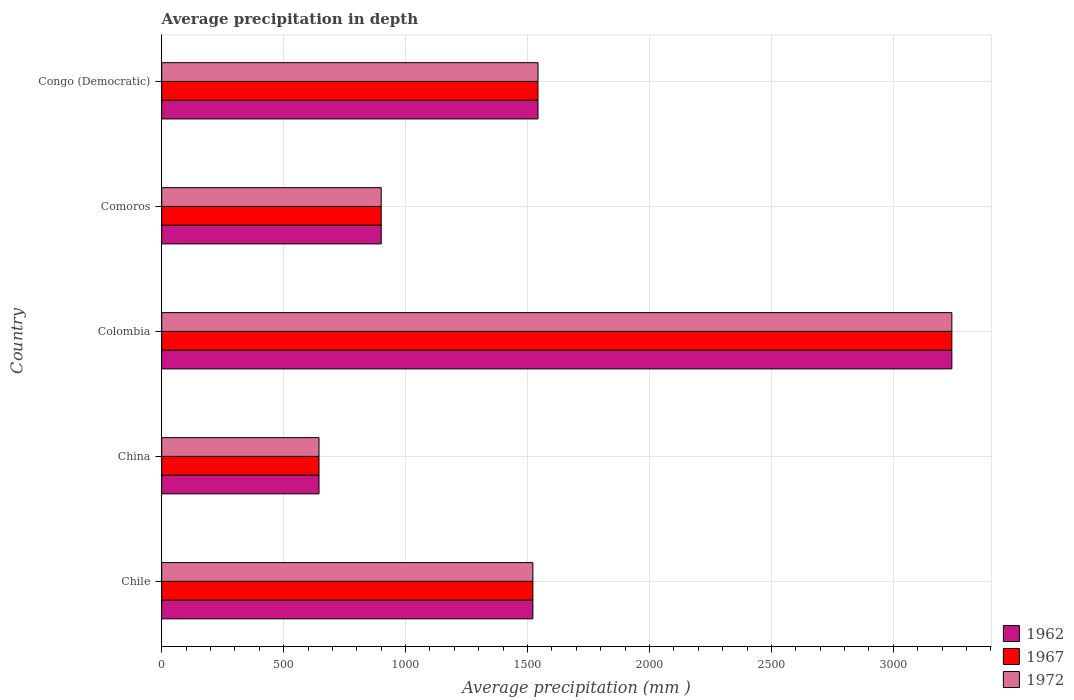How many different coloured bars are there?
Your answer should be very brief. 3. How many groups of bars are there?
Provide a succinct answer. 5. How many bars are there on the 1st tick from the top?
Your answer should be compact. 3. What is the label of the 4th group of bars from the top?
Ensure brevity in your answer.  China. In how many cases, is the number of bars for a given country not equal to the number of legend labels?
Your response must be concise. 0. What is the average precipitation in 1967 in Colombia?
Make the answer very short. 3240. Across all countries, what is the maximum average precipitation in 1967?
Offer a very short reply. 3240. Across all countries, what is the minimum average precipitation in 1972?
Your answer should be very brief. 645. In which country was the average precipitation in 1967 minimum?
Provide a succinct answer. China. What is the total average precipitation in 1967 in the graph?
Provide a succinct answer. 7850. What is the difference between the average precipitation in 1972 in Chile and that in Congo (Democratic)?
Your response must be concise. -21. What is the difference between the average precipitation in 1962 in Chile and the average precipitation in 1967 in Colombia?
Your answer should be compact. -1718. What is the average average precipitation in 1967 per country?
Offer a very short reply. 1570. What is the ratio of the average precipitation in 1962 in Chile to that in Congo (Democratic)?
Keep it short and to the point. 0.99. What is the difference between the highest and the second highest average precipitation in 1967?
Your answer should be very brief. 1697. What is the difference between the highest and the lowest average precipitation in 1972?
Your response must be concise. 2595. In how many countries, is the average precipitation in 1962 greater than the average average precipitation in 1962 taken over all countries?
Ensure brevity in your answer.  1. Is the sum of the average precipitation in 1962 in Colombia and Comoros greater than the maximum average precipitation in 1972 across all countries?
Provide a short and direct response. Yes. What does the 2nd bar from the top in Colombia represents?
Offer a very short reply. 1967. Is it the case that in every country, the sum of the average precipitation in 1972 and average precipitation in 1962 is greater than the average precipitation in 1967?
Your answer should be very brief. Yes. Are all the bars in the graph horizontal?
Give a very brief answer. Yes. What is the difference between two consecutive major ticks on the X-axis?
Your answer should be very brief. 500. Are the values on the major ticks of X-axis written in scientific E-notation?
Offer a very short reply. No. Does the graph contain grids?
Give a very brief answer. Yes. Where does the legend appear in the graph?
Provide a succinct answer. Bottom right. What is the title of the graph?
Give a very brief answer. Average precipitation in depth. Does "2011" appear as one of the legend labels in the graph?
Your response must be concise. No. What is the label or title of the X-axis?
Your answer should be very brief. Average precipitation (mm ). What is the label or title of the Y-axis?
Offer a terse response. Country. What is the Average precipitation (mm ) of 1962 in Chile?
Provide a short and direct response. 1522. What is the Average precipitation (mm ) of 1967 in Chile?
Offer a terse response. 1522. What is the Average precipitation (mm ) in 1972 in Chile?
Give a very brief answer. 1522. What is the Average precipitation (mm ) in 1962 in China?
Offer a terse response. 645. What is the Average precipitation (mm ) in 1967 in China?
Your response must be concise. 645. What is the Average precipitation (mm ) of 1972 in China?
Provide a short and direct response. 645. What is the Average precipitation (mm ) in 1962 in Colombia?
Your response must be concise. 3240. What is the Average precipitation (mm ) in 1967 in Colombia?
Provide a succinct answer. 3240. What is the Average precipitation (mm ) of 1972 in Colombia?
Offer a terse response. 3240. What is the Average precipitation (mm ) of 1962 in Comoros?
Keep it short and to the point. 900. What is the Average precipitation (mm ) of 1967 in Comoros?
Offer a very short reply. 900. What is the Average precipitation (mm ) in 1972 in Comoros?
Ensure brevity in your answer.  900. What is the Average precipitation (mm ) of 1962 in Congo (Democratic)?
Your answer should be very brief. 1543. What is the Average precipitation (mm ) of 1967 in Congo (Democratic)?
Keep it short and to the point. 1543. What is the Average precipitation (mm ) in 1972 in Congo (Democratic)?
Keep it short and to the point. 1543. Across all countries, what is the maximum Average precipitation (mm ) of 1962?
Provide a short and direct response. 3240. Across all countries, what is the maximum Average precipitation (mm ) of 1967?
Your answer should be compact. 3240. Across all countries, what is the maximum Average precipitation (mm ) in 1972?
Offer a terse response. 3240. Across all countries, what is the minimum Average precipitation (mm ) in 1962?
Ensure brevity in your answer.  645. Across all countries, what is the minimum Average precipitation (mm ) of 1967?
Make the answer very short. 645. Across all countries, what is the minimum Average precipitation (mm ) in 1972?
Offer a very short reply. 645. What is the total Average precipitation (mm ) of 1962 in the graph?
Ensure brevity in your answer.  7850. What is the total Average precipitation (mm ) in 1967 in the graph?
Give a very brief answer. 7850. What is the total Average precipitation (mm ) of 1972 in the graph?
Keep it short and to the point. 7850. What is the difference between the Average precipitation (mm ) of 1962 in Chile and that in China?
Ensure brevity in your answer.  877. What is the difference between the Average precipitation (mm ) in 1967 in Chile and that in China?
Give a very brief answer. 877. What is the difference between the Average precipitation (mm ) in 1972 in Chile and that in China?
Offer a very short reply. 877. What is the difference between the Average precipitation (mm ) of 1962 in Chile and that in Colombia?
Your answer should be very brief. -1718. What is the difference between the Average precipitation (mm ) in 1967 in Chile and that in Colombia?
Provide a short and direct response. -1718. What is the difference between the Average precipitation (mm ) in 1972 in Chile and that in Colombia?
Keep it short and to the point. -1718. What is the difference between the Average precipitation (mm ) of 1962 in Chile and that in Comoros?
Ensure brevity in your answer.  622. What is the difference between the Average precipitation (mm ) in 1967 in Chile and that in Comoros?
Your response must be concise. 622. What is the difference between the Average precipitation (mm ) of 1972 in Chile and that in Comoros?
Your response must be concise. 622. What is the difference between the Average precipitation (mm ) of 1962 in China and that in Colombia?
Your answer should be compact. -2595. What is the difference between the Average precipitation (mm ) in 1967 in China and that in Colombia?
Make the answer very short. -2595. What is the difference between the Average precipitation (mm ) of 1972 in China and that in Colombia?
Your answer should be compact. -2595. What is the difference between the Average precipitation (mm ) of 1962 in China and that in Comoros?
Keep it short and to the point. -255. What is the difference between the Average precipitation (mm ) in 1967 in China and that in Comoros?
Your answer should be very brief. -255. What is the difference between the Average precipitation (mm ) in 1972 in China and that in Comoros?
Give a very brief answer. -255. What is the difference between the Average precipitation (mm ) in 1962 in China and that in Congo (Democratic)?
Offer a terse response. -898. What is the difference between the Average precipitation (mm ) of 1967 in China and that in Congo (Democratic)?
Provide a short and direct response. -898. What is the difference between the Average precipitation (mm ) of 1972 in China and that in Congo (Democratic)?
Keep it short and to the point. -898. What is the difference between the Average precipitation (mm ) in 1962 in Colombia and that in Comoros?
Your answer should be very brief. 2340. What is the difference between the Average precipitation (mm ) of 1967 in Colombia and that in Comoros?
Give a very brief answer. 2340. What is the difference between the Average precipitation (mm ) in 1972 in Colombia and that in Comoros?
Ensure brevity in your answer.  2340. What is the difference between the Average precipitation (mm ) in 1962 in Colombia and that in Congo (Democratic)?
Keep it short and to the point. 1697. What is the difference between the Average precipitation (mm ) in 1967 in Colombia and that in Congo (Democratic)?
Keep it short and to the point. 1697. What is the difference between the Average precipitation (mm ) in 1972 in Colombia and that in Congo (Democratic)?
Make the answer very short. 1697. What is the difference between the Average precipitation (mm ) of 1962 in Comoros and that in Congo (Democratic)?
Offer a very short reply. -643. What is the difference between the Average precipitation (mm ) in 1967 in Comoros and that in Congo (Democratic)?
Give a very brief answer. -643. What is the difference between the Average precipitation (mm ) in 1972 in Comoros and that in Congo (Democratic)?
Offer a very short reply. -643. What is the difference between the Average precipitation (mm ) in 1962 in Chile and the Average precipitation (mm ) in 1967 in China?
Your answer should be very brief. 877. What is the difference between the Average precipitation (mm ) in 1962 in Chile and the Average precipitation (mm ) in 1972 in China?
Keep it short and to the point. 877. What is the difference between the Average precipitation (mm ) in 1967 in Chile and the Average precipitation (mm ) in 1972 in China?
Keep it short and to the point. 877. What is the difference between the Average precipitation (mm ) of 1962 in Chile and the Average precipitation (mm ) of 1967 in Colombia?
Your answer should be very brief. -1718. What is the difference between the Average precipitation (mm ) of 1962 in Chile and the Average precipitation (mm ) of 1972 in Colombia?
Ensure brevity in your answer.  -1718. What is the difference between the Average precipitation (mm ) of 1967 in Chile and the Average precipitation (mm ) of 1972 in Colombia?
Your answer should be compact. -1718. What is the difference between the Average precipitation (mm ) of 1962 in Chile and the Average precipitation (mm ) of 1967 in Comoros?
Your response must be concise. 622. What is the difference between the Average precipitation (mm ) in 1962 in Chile and the Average precipitation (mm ) in 1972 in Comoros?
Provide a short and direct response. 622. What is the difference between the Average precipitation (mm ) of 1967 in Chile and the Average precipitation (mm ) of 1972 in Comoros?
Give a very brief answer. 622. What is the difference between the Average precipitation (mm ) of 1962 in Chile and the Average precipitation (mm ) of 1972 in Congo (Democratic)?
Your answer should be very brief. -21. What is the difference between the Average precipitation (mm ) in 1967 in Chile and the Average precipitation (mm ) in 1972 in Congo (Democratic)?
Give a very brief answer. -21. What is the difference between the Average precipitation (mm ) in 1962 in China and the Average precipitation (mm ) in 1967 in Colombia?
Your answer should be compact. -2595. What is the difference between the Average precipitation (mm ) of 1962 in China and the Average precipitation (mm ) of 1972 in Colombia?
Give a very brief answer. -2595. What is the difference between the Average precipitation (mm ) of 1967 in China and the Average precipitation (mm ) of 1972 in Colombia?
Offer a terse response. -2595. What is the difference between the Average precipitation (mm ) of 1962 in China and the Average precipitation (mm ) of 1967 in Comoros?
Your answer should be compact. -255. What is the difference between the Average precipitation (mm ) of 1962 in China and the Average precipitation (mm ) of 1972 in Comoros?
Offer a very short reply. -255. What is the difference between the Average precipitation (mm ) of 1967 in China and the Average precipitation (mm ) of 1972 in Comoros?
Your response must be concise. -255. What is the difference between the Average precipitation (mm ) of 1962 in China and the Average precipitation (mm ) of 1967 in Congo (Democratic)?
Offer a terse response. -898. What is the difference between the Average precipitation (mm ) of 1962 in China and the Average precipitation (mm ) of 1972 in Congo (Democratic)?
Offer a very short reply. -898. What is the difference between the Average precipitation (mm ) in 1967 in China and the Average precipitation (mm ) in 1972 in Congo (Democratic)?
Your response must be concise. -898. What is the difference between the Average precipitation (mm ) in 1962 in Colombia and the Average precipitation (mm ) in 1967 in Comoros?
Make the answer very short. 2340. What is the difference between the Average precipitation (mm ) of 1962 in Colombia and the Average precipitation (mm ) of 1972 in Comoros?
Ensure brevity in your answer.  2340. What is the difference between the Average precipitation (mm ) in 1967 in Colombia and the Average precipitation (mm ) in 1972 in Comoros?
Your response must be concise. 2340. What is the difference between the Average precipitation (mm ) of 1962 in Colombia and the Average precipitation (mm ) of 1967 in Congo (Democratic)?
Provide a short and direct response. 1697. What is the difference between the Average precipitation (mm ) in 1962 in Colombia and the Average precipitation (mm ) in 1972 in Congo (Democratic)?
Provide a succinct answer. 1697. What is the difference between the Average precipitation (mm ) of 1967 in Colombia and the Average precipitation (mm ) of 1972 in Congo (Democratic)?
Your answer should be compact. 1697. What is the difference between the Average precipitation (mm ) in 1962 in Comoros and the Average precipitation (mm ) in 1967 in Congo (Democratic)?
Ensure brevity in your answer.  -643. What is the difference between the Average precipitation (mm ) in 1962 in Comoros and the Average precipitation (mm ) in 1972 in Congo (Democratic)?
Your response must be concise. -643. What is the difference between the Average precipitation (mm ) of 1967 in Comoros and the Average precipitation (mm ) of 1972 in Congo (Democratic)?
Give a very brief answer. -643. What is the average Average precipitation (mm ) in 1962 per country?
Your answer should be very brief. 1570. What is the average Average precipitation (mm ) in 1967 per country?
Ensure brevity in your answer.  1570. What is the average Average precipitation (mm ) of 1972 per country?
Ensure brevity in your answer.  1570. What is the difference between the Average precipitation (mm ) of 1962 and Average precipitation (mm ) of 1967 in Chile?
Give a very brief answer. 0. What is the difference between the Average precipitation (mm ) in 1967 and Average precipitation (mm ) in 1972 in Chile?
Provide a succinct answer. 0. What is the difference between the Average precipitation (mm ) of 1962 and Average precipitation (mm ) of 1972 in China?
Offer a very short reply. 0. What is the difference between the Average precipitation (mm ) of 1962 and Average precipitation (mm ) of 1972 in Comoros?
Give a very brief answer. 0. What is the difference between the Average precipitation (mm ) in 1967 and Average precipitation (mm ) in 1972 in Comoros?
Make the answer very short. 0. What is the difference between the Average precipitation (mm ) of 1962 and Average precipitation (mm ) of 1967 in Congo (Democratic)?
Offer a very short reply. 0. What is the difference between the Average precipitation (mm ) of 1962 and Average precipitation (mm ) of 1972 in Congo (Democratic)?
Keep it short and to the point. 0. What is the ratio of the Average precipitation (mm ) in 1962 in Chile to that in China?
Give a very brief answer. 2.36. What is the ratio of the Average precipitation (mm ) of 1967 in Chile to that in China?
Your answer should be very brief. 2.36. What is the ratio of the Average precipitation (mm ) of 1972 in Chile to that in China?
Your answer should be very brief. 2.36. What is the ratio of the Average precipitation (mm ) in 1962 in Chile to that in Colombia?
Ensure brevity in your answer.  0.47. What is the ratio of the Average precipitation (mm ) of 1967 in Chile to that in Colombia?
Offer a terse response. 0.47. What is the ratio of the Average precipitation (mm ) of 1972 in Chile to that in Colombia?
Provide a short and direct response. 0.47. What is the ratio of the Average precipitation (mm ) of 1962 in Chile to that in Comoros?
Your answer should be compact. 1.69. What is the ratio of the Average precipitation (mm ) of 1967 in Chile to that in Comoros?
Your answer should be very brief. 1.69. What is the ratio of the Average precipitation (mm ) of 1972 in Chile to that in Comoros?
Offer a very short reply. 1.69. What is the ratio of the Average precipitation (mm ) of 1962 in Chile to that in Congo (Democratic)?
Your answer should be compact. 0.99. What is the ratio of the Average precipitation (mm ) of 1967 in Chile to that in Congo (Democratic)?
Provide a short and direct response. 0.99. What is the ratio of the Average precipitation (mm ) in 1972 in Chile to that in Congo (Democratic)?
Provide a short and direct response. 0.99. What is the ratio of the Average precipitation (mm ) in 1962 in China to that in Colombia?
Give a very brief answer. 0.2. What is the ratio of the Average precipitation (mm ) of 1967 in China to that in Colombia?
Your answer should be compact. 0.2. What is the ratio of the Average precipitation (mm ) in 1972 in China to that in Colombia?
Give a very brief answer. 0.2. What is the ratio of the Average precipitation (mm ) of 1962 in China to that in Comoros?
Provide a succinct answer. 0.72. What is the ratio of the Average precipitation (mm ) of 1967 in China to that in Comoros?
Provide a succinct answer. 0.72. What is the ratio of the Average precipitation (mm ) of 1972 in China to that in Comoros?
Ensure brevity in your answer.  0.72. What is the ratio of the Average precipitation (mm ) in 1962 in China to that in Congo (Democratic)?
Your answer should be very brief. 0.42. What is the ratio of the Average precipitation (mm ) of 1967 in China to that in Congo (Democratic)?
Your response must be concise. 0.42. What is the ratio of the Average precipitation (mm ) of 1972 in China to that in Congo (Democratic)?
Offer a very short reply. 0.42. What is the ratio of the Average precipitation (mm ) in 1962 in Colombia to that in Comoros?
Ensure brevity in your answer.  3.6. What is the ratio of the Average precipitation (mm ) of 1972 in Colombia to that in Comoros?
Ensure brevity in your answer.  3.6. What is the ratio of the Average precipitation (mm ) in 1962 in Colombia to that in Congo (Democratic)?
Offer a terse response. 2.1. What is the ratio of the Average precipitation (mm ) of 1967 in Colombia to that in Congo (Democratic)?
Make the answer very short. 2.1. What is the ratio of the Average precipitation (mm ) in 1972 in Colombia to that in Congo (Democratic)?
Keep it short and to the point. 2.1. What is the ratio of the Average precipitation (mm ) in 1962 in Comoros to that in Congo (Democratic)?
Your answer should be very brief. 0.58. What is the ratio of the Average precipitation (mm ) of 1967 in Comoros to that in Congo (Democratic)?
Keep it short and to the point. 0.58. What is the ratio of the Average precipitation (mm ) in 1972 in Comoros to that in Congo (Democratic)?
Make the answer very short. 0.58. What is the difference between the highest and the second highest Average precipitation (mm ) of 1962?
Ensure brevity in your answer.  1697. What is the difference between the highest and the second highest Average precipitation (mm ) of 1967?
Ensure brevity in your answer.  1697. What is the difference between the highest and the second highest Average precipitation (mm ) of 1972?
Make the answer very short. 1697. What is the difference between the highest and the lowest Average precipitation (mm ) in 1962?
Keep it short and to the point. 2595. What is the difference between the highest and the lowest Average precipitation (mm ) of 1967?
Offer a very short reply. 2595. What is the difference between the highest and the lowest Average precipitation (mm ) of 1972?
Offer a very short reply. 2595. 